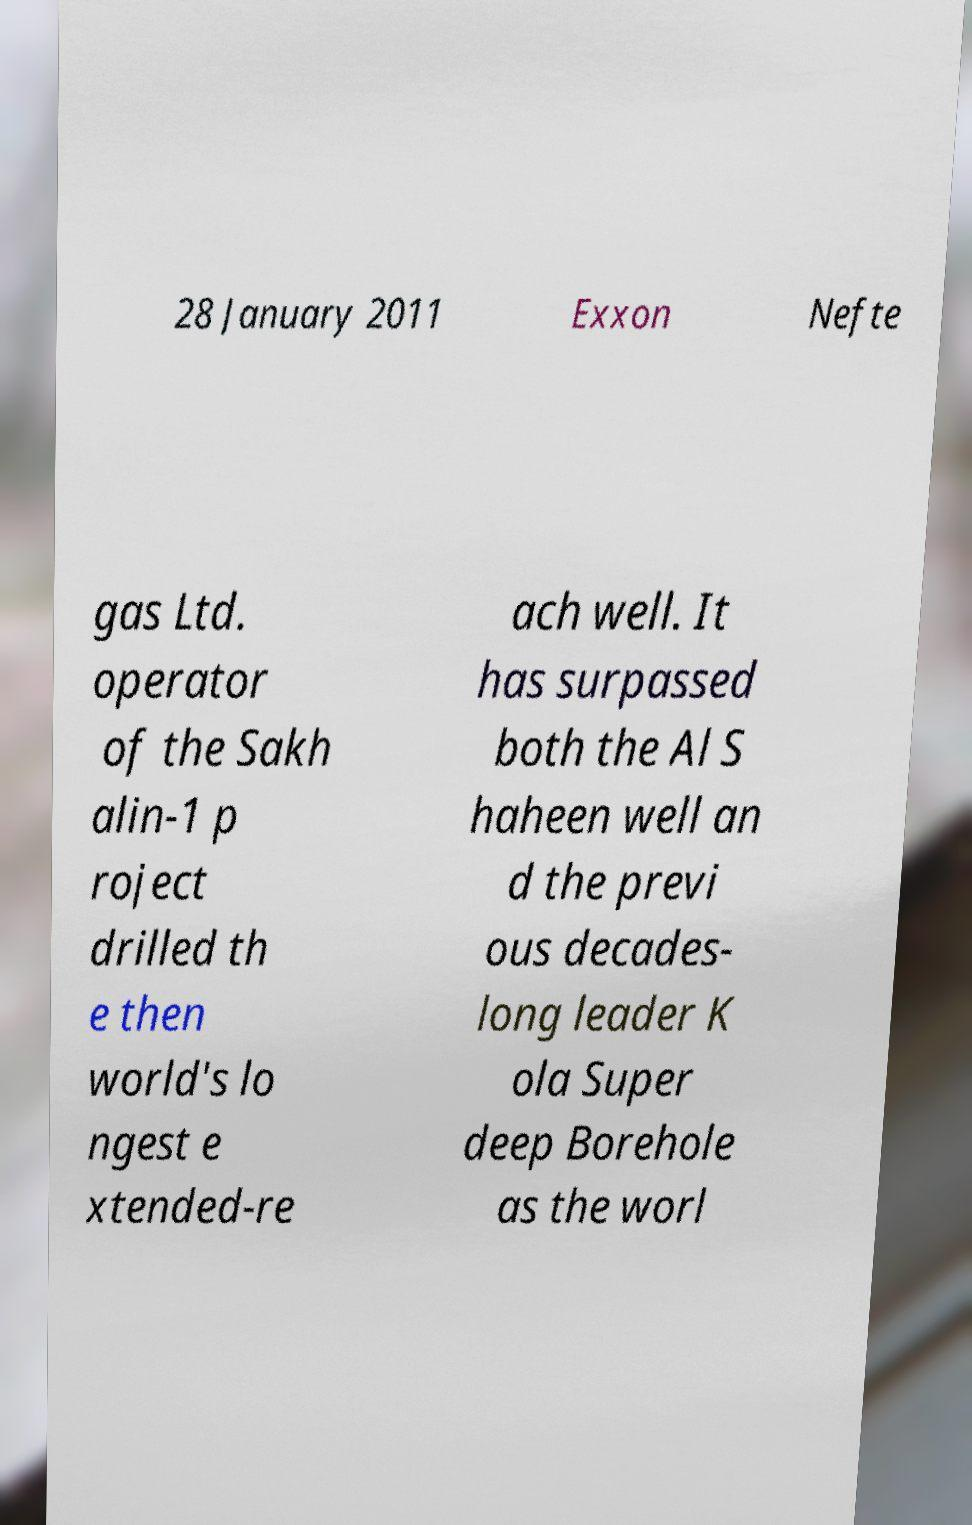Please read and relay the text visible in this image. What does it say? 28 January 2011 Exxon Nefte gas Ltd. operator of the Sakh alin-1 p roject drilled th e then world's lo ngest e xtended-re ach well. It has surpassed both the Al S haheen well an d the previ ous decades- long leader K ola Super deep Borehole as the worl 